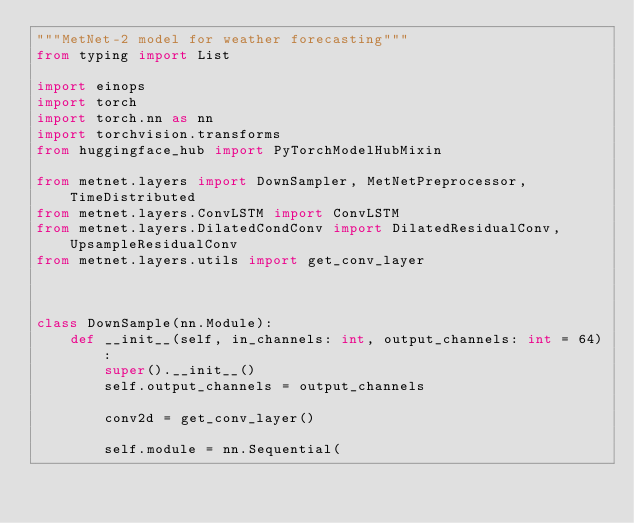<code> <loc_0><loc_0><loc_500><loc_500><_Python_>"""MetNet-2 model for weather forecasting"""
from typing import List

import einops
import torch
import torch.nn as nn
import torchvision.transforms
from huggingface_hub import PyTorchModelHubMixin

from metnet.layers import DownSampler, MetNetPreprocessor, TimeDistributed
from metnet.layers.ConvLSTM import ConvLSTM
from metnet.layers.DilatedCondConv import DilatedResidualConv, UpsampleResidualConv
from metnet.layers.utils import get_conv_layer



class DownSample(nn.Module):
    def __init__(self, in_channels: int, output_channels: int = 64):
        super().__init__()
        self.output_channels = output_channels

        conv2d = get_conv_layer()

        self.module = nn.Sequential(</code> 